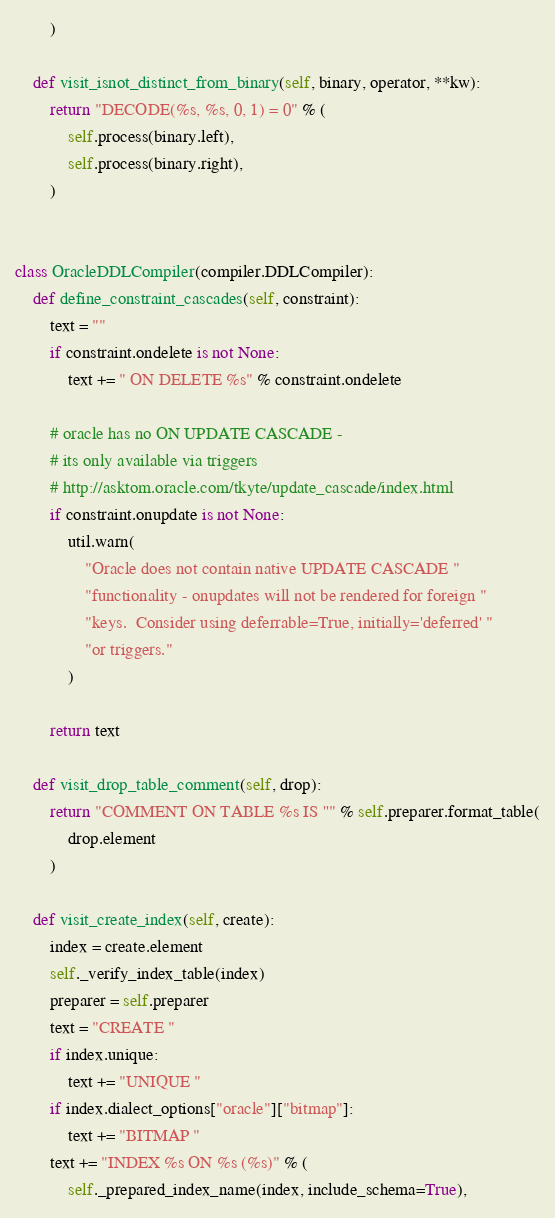Convert code to text. <code><loc_0><loc_0><loc_500><loc_500><_Python_>        )

    def visit_isnot_distinct_from_binary(self, binary, operator, **kw):
        return "DECODE(%s, %s, 0, 1) = 0" % (
            self.process(binary.left),
            self.process(binary.right),
        )


class OracleDDLCompiler(compiler.DDLCompiler):
    def define_constraint_cascades(self, constraint):
        text = ""
        if constraint.ondelete is not None:
            text += " ON DELETE %s" % constraint.ondelete

        # oracle has no ON UPDATE CASCADE -
        # its only available via triggers
        # http://asktom.oracle.com/tkyte/update_cascade/index.html
        if constraint.onupdate is not None:
            util.warn(
                "Oracle does not contain native UPDATE CASCADE "
                "functionality - onupdates will not be rendered for foreign "
                "keys.  Consider using deferrable=True, initially='deferred' "
                "or triggers."
            )

        return text

    def visit_drop_table_comment(self, drop):
        return "COMMENT ON TABLE %s IS ''" % self.preparer.format_table(
            drop.element
        )

    def visit_create_index(self, create):
        index = create.element
        self._verify_index_table(index)
        preparer = self.preparer
        text = "CREATE "
        if index.unique:
            text += "UNIQUE "
        if index.dialect_options["oracle"]["bitmap"]:
            text += "BITMAP "
        text += "INDEX %s ON %s (%s)" % (
            self._prepared_index_name(index, include_schema=True),</code> 